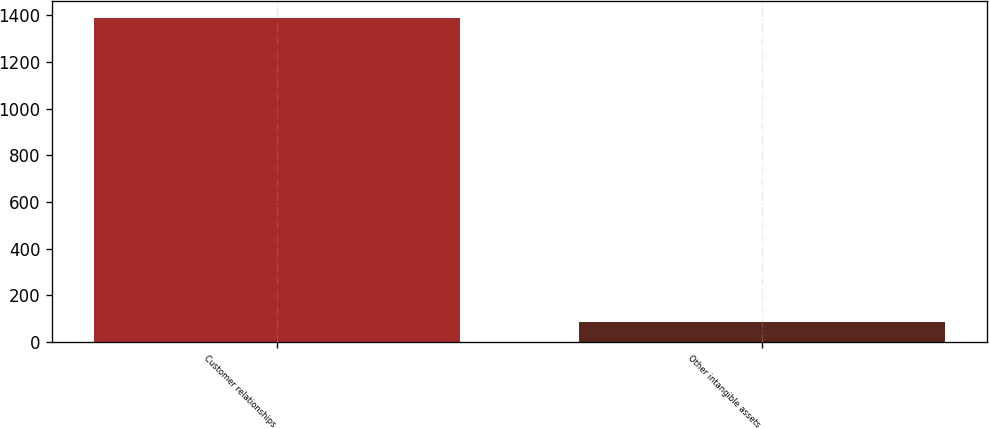Convert chart. <chart><loc_0><loc_0><loc_500><loc_500><bar_chart><fcel>Customer relationships<fcel>Other intangible assets<nl><fcel>1389<fcel>86<nl></chart> 